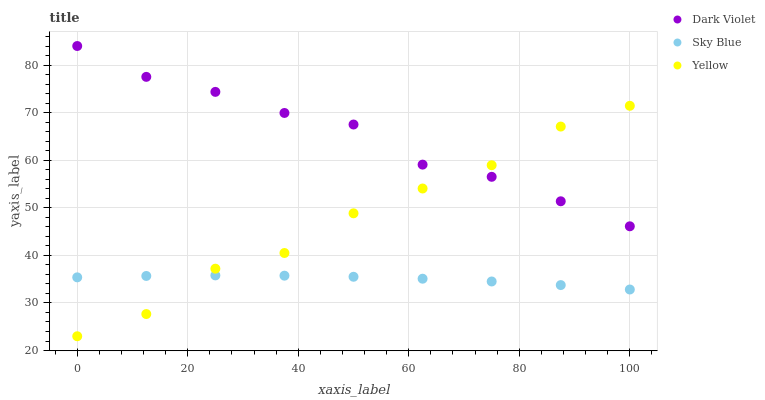Does Sky Blue have the minimum area under the curve?
Answer yes or no. Yes. Does Dark Violet have the maximum area under the curve?
Answer yes or no. Yes. Does Yellow have the minimum area under the curve?
Answer yes or no. No. Does Yellow have the maximum area under the curve?
Answer yes or no. No. Is Sky Blue the smoothest?
Answer yes or no. Yes. Is Yellow the roughest?
Answer yes or no. Yes. Is Dark Violet the smoothest?
Answer yes or no. No. Is Dark Violet the roughest?
Answer yes or no. No. Does Yellow have the lowest value?
Answer yes or no. Yes. Does Dark Violet have the lowest value?
Answer yes or no. No. Does Dark Violet have the highest value?
Answer yes or no. Yes. Does Yellow have the highest value?
Answer yes or no. No. Is Sky Blue less than Dark Violet?
Answer yes or no. Yes. Is Dark Violet greater than Sky Blue?
Answer yes or no. Yes. Does Sky Blue intersect Yellow?
Answer yes or no. Yes. Is Sky Blue less than Yellow?
Answer yes or no. No. Is Sky Blue greater than Yellow?
Answer yes or no. No. Does Sky Blue intersect Dark Violet?
Answer yes or no. No. 